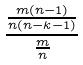<formula> <loc_0><loc_0><loc_500><loc_500>\frac { \frac { m ( n - 1 ) } { n ( n - k - 1 ) } } { \frac { m } { n } }</formula> 